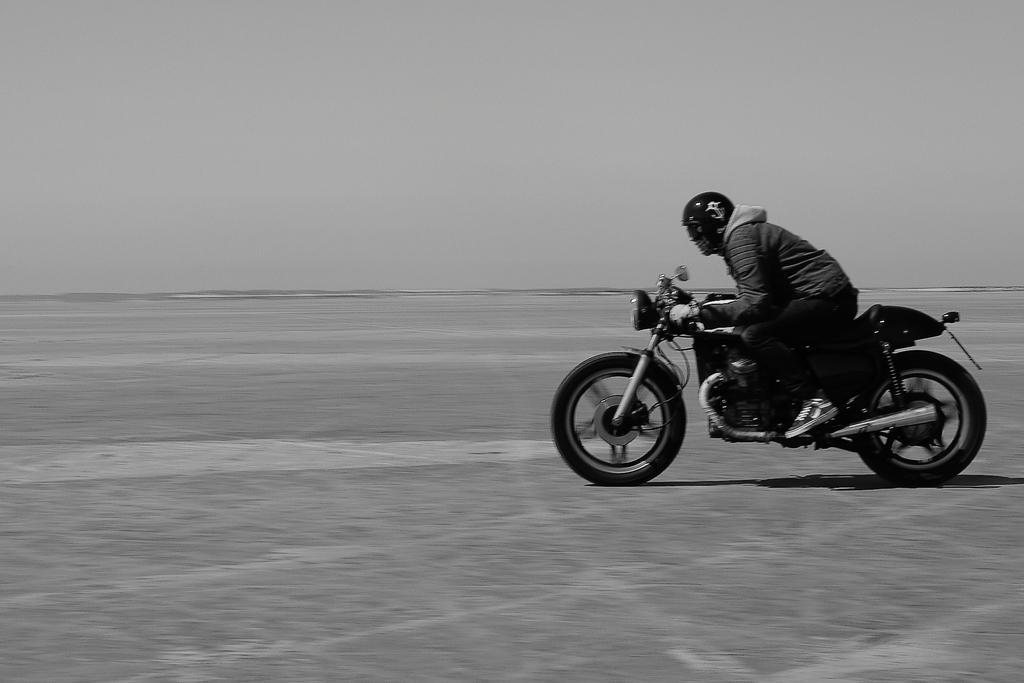Could you give a brief overview of what you see in this image? Here a man is riding bike on the road. In the background there is a sky. 